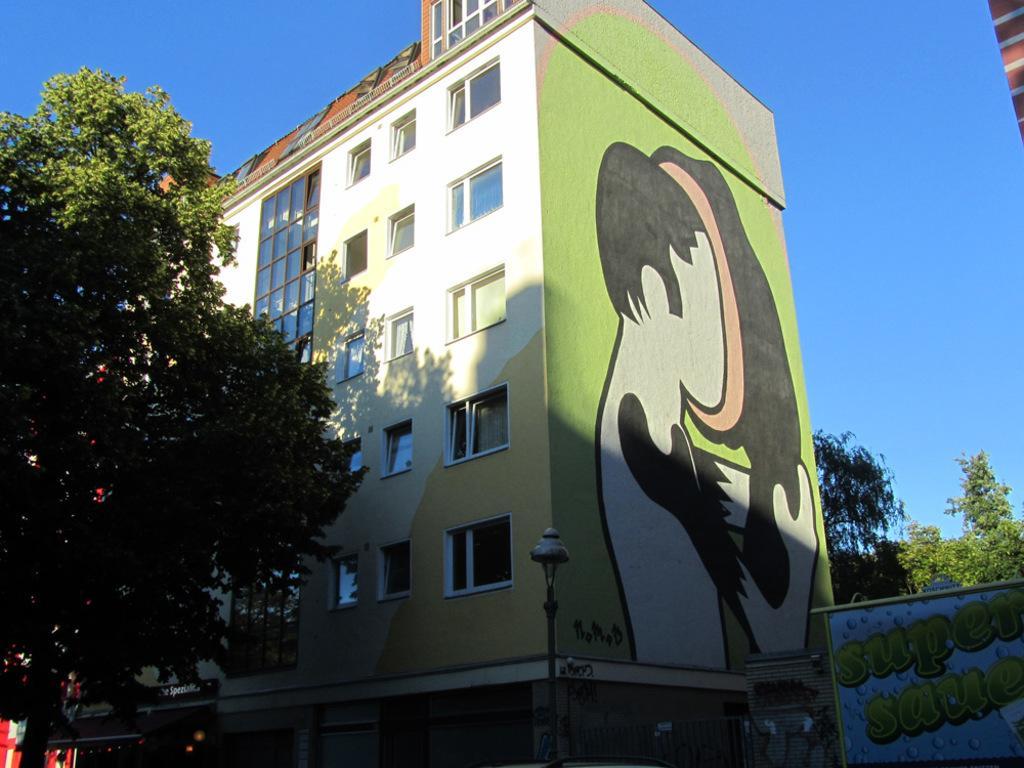Can you describe this image briefly? In this picture we can see a light pole, board, some objects, trees, building with windows, painting on the wall and in the background we can see the sky. 